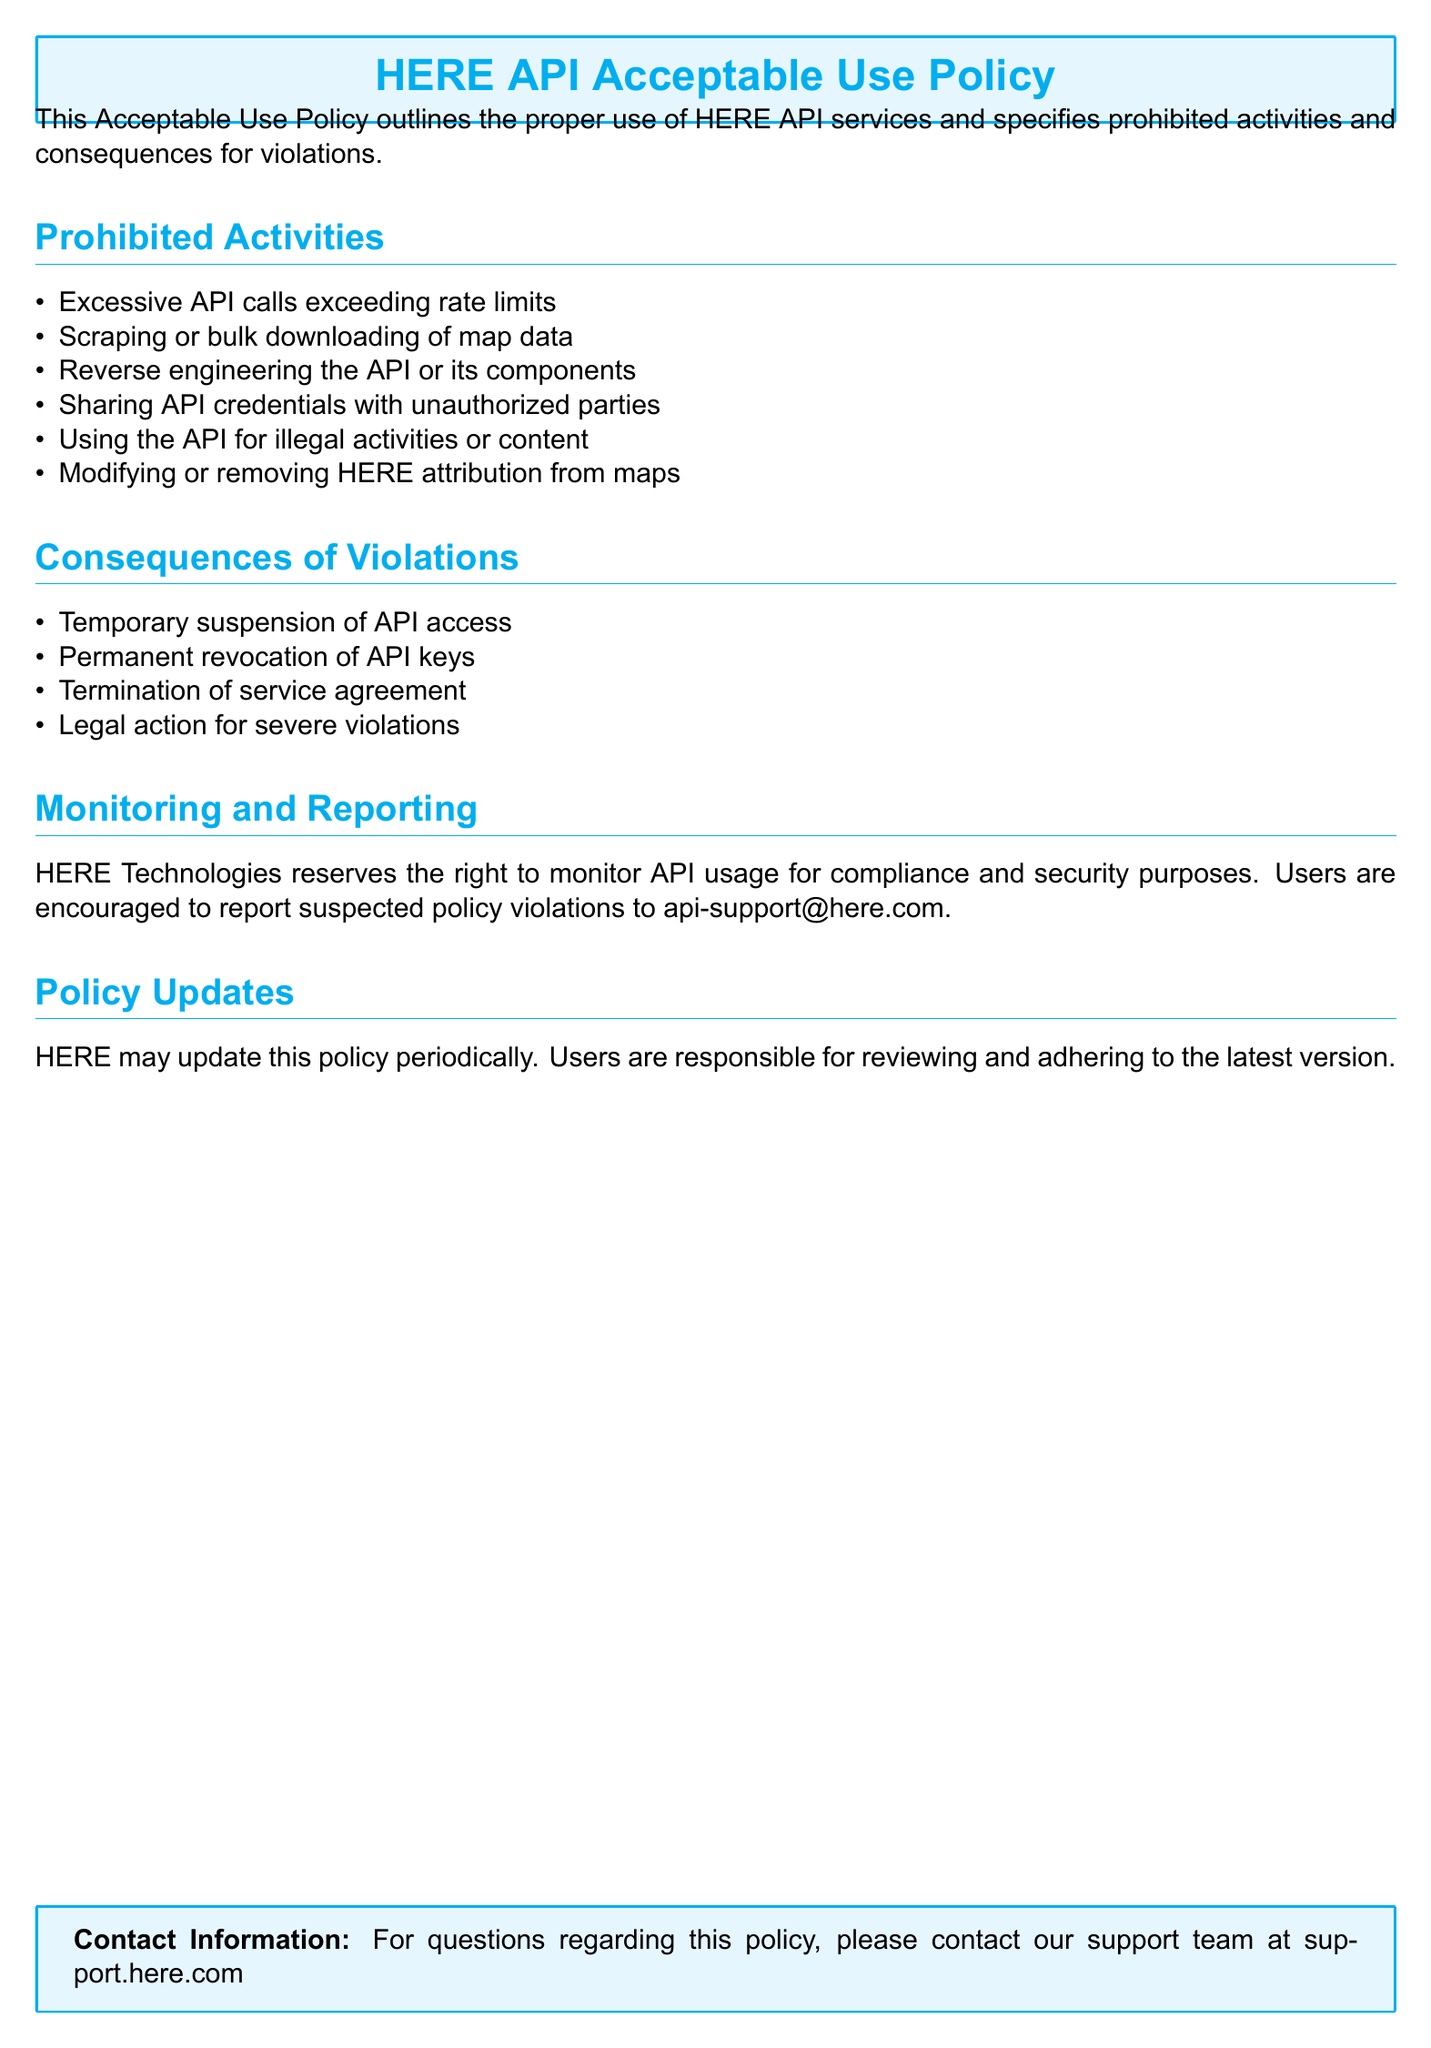What is the title of the document? The title of the document is stated at the beginning and is emphasized in a box format.
Answer: HERE API Acceptable Use Policy What is a prohibited activity related to API calls? The document specifies excessive API calls which exceed set limits as a prohibited activity.
Answer: Excessive API calls exceeding rate limits What can happen if someone shares API credentials? The document clearly states that sharing API credentials with unauthorized parties is prohibited and may lead to consequences.
Answer: Permanent revocation of API keys How many consequences of violations are listed? The number of consequences is indicated by the total listed under the "Consequences of Violations" section.
Answer: Four What is one legal consequence mentioned for severe violations? The document specifies that severe violations may result in legal actions, which is identified under the consequences section.
Answer: Legal action for severe violations What is the purpose of monitoring API usage? The document indicates that monitoring is conducted for compliance and security purposes, highlighting the importance of these actions.
Answer: Compliance and security What email address can be used to report suspected violations? The document provides a specific email address for reporting, which is crucial for compliance enforcement.
Answer: api-support@here.com What are users responsible for regarding policy updates? The document states that users need to keep track of any changes made to the policy and is clarified in the "Policy Updates" section.
Answer: Reviewing and adhering to the latest version 